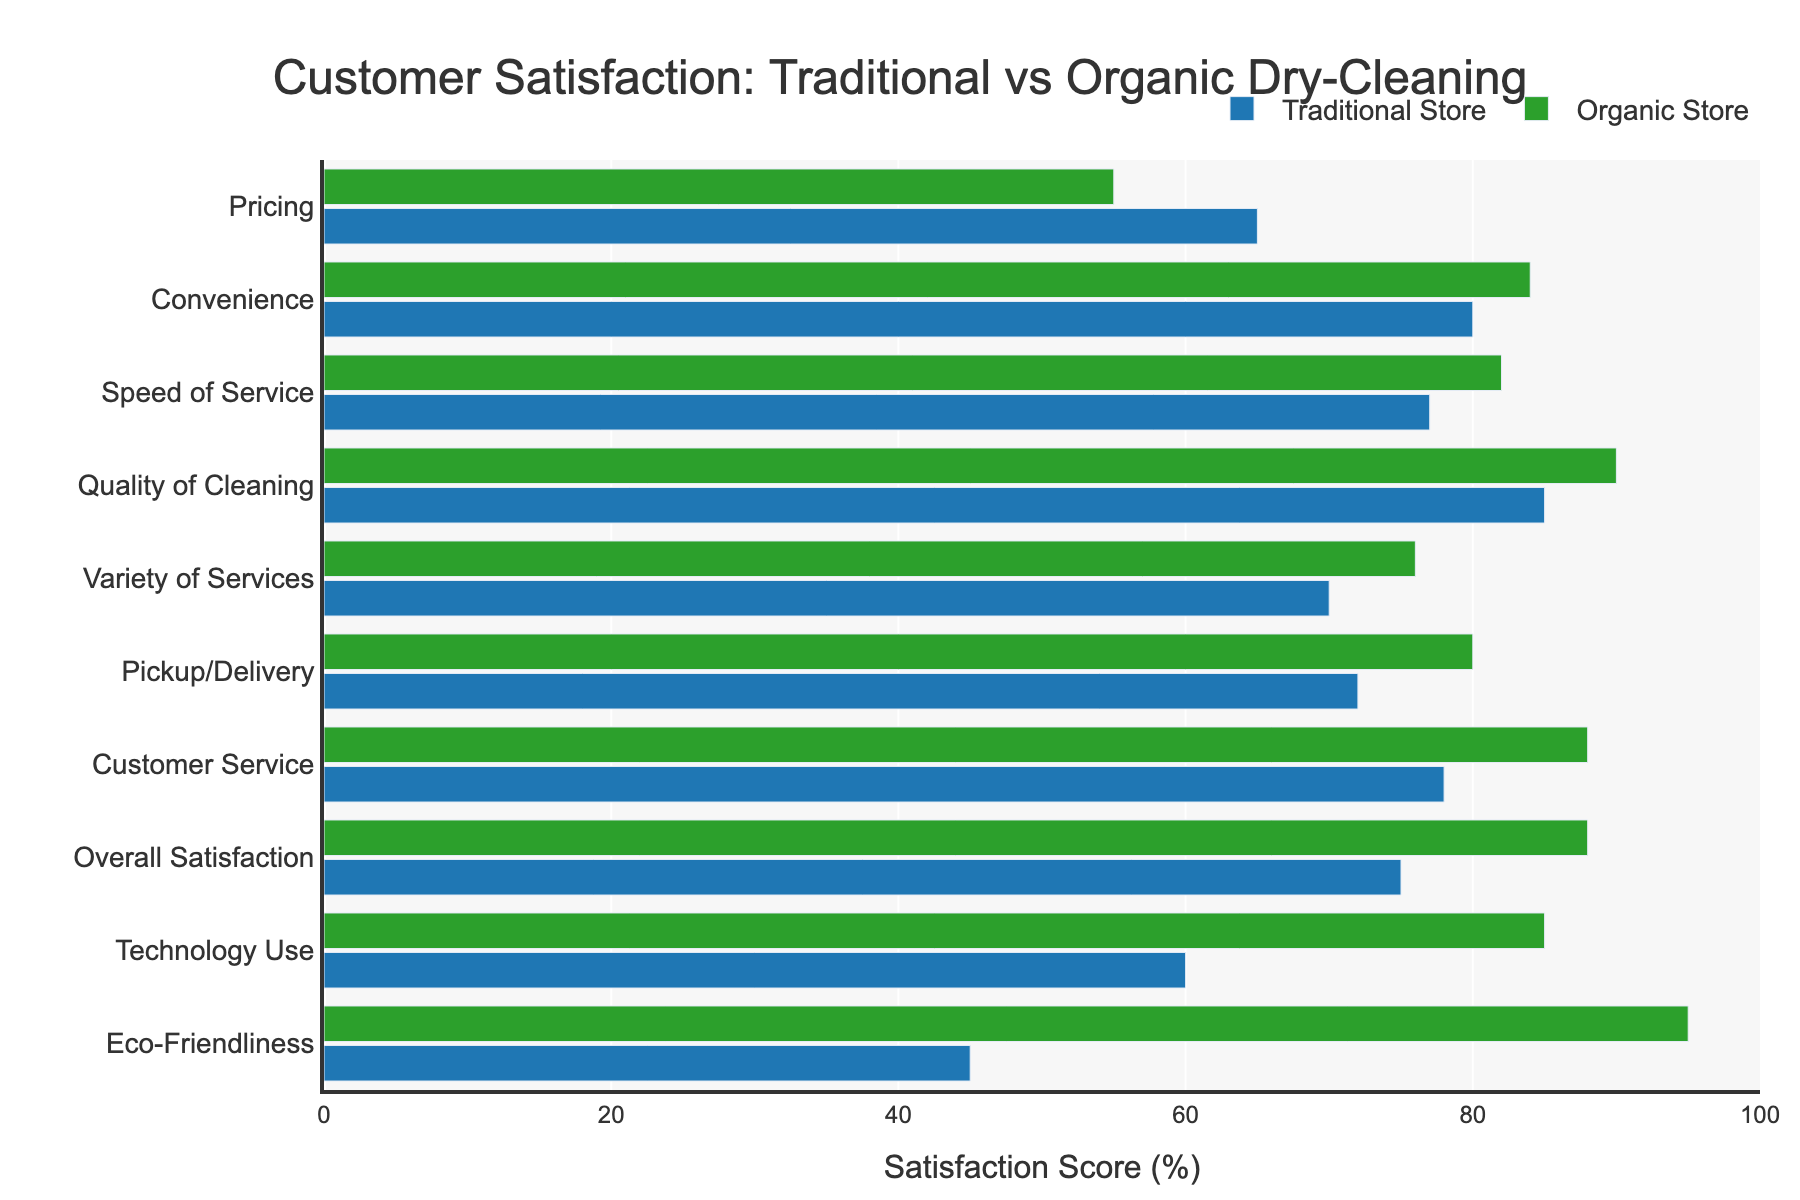Which satisfaction metric shows the largest difference in scores between traditional and organic stores? The largest difference can be found by looking for the metric with the longest bar gap between traditional and organic stores. 'Eco-Friendliness' has the largest difference with a score gap of 50% (traditional 45% vs organic 95%).
Answer: 'Eco-Friendliness' For which satisfaction metric do traditional stores score higher than organic stores? By checking the bars, traditional stores score higher than organic stores in:
- 'Pricing': 65% (traditional) vs 55% (organic)
Answer: 'Pricing' Which store type has a higher overall satisfaction score? By observing the bars for 'Overall Satisfaction', organic stores score 88% whereas traditional stores score 75%. Hence, organic stores have a higher overall satisfaction.
Answer: Organic stores What's the combined satisfaction score for organic stores in 'Customer Service' and 'Quality of Cleaning'? For organic stores, the 'Customer Service' score is 88% and 'Quality of Cleaning' score is 90%. The combined score is 88 + 90 = 178%.
Answer: 178% Which satisfaction metric shows the smallest difference in scores between traditional and organic stores? The smallest difference can be identified by looking for the metric with the closest bars. 'Convenience' shows the smallest difference where traditional stores score 80% and organic stores score 84%, translating to a 4% difference.
Answer: 'Convenience' Which metrics have a score of 80% or higher for traditional stores? The metrics with scores of 80% or higher for traditional stores are:
- 'Quality of Cleaning': 85%
- 'Convenience': 80%
Answer: 'Quality of Cleaning', 'Convenience' What is the average satisfaction score for traditional stores across all metrics? Adding up all the scores for traditional stores: 85 + 78 + 65 + 72 + 45 + 80 + 77 + 70 + 60 + 75 = 707%. Then, divide by the number of metrics, which is 10. So, the average score is 707/10 = 70.7%.
Answer: 70.7% How much higher is the 'Technology Use' score for organic stores compared to traditional stores? The 'Technology Use' score for organic stores is 85% and for traditional stores is 60%. The difference is 85 - 60 = 25%.
Answer: 25% Which metrics do organic stores score at least 10% higher than traditional stores? The metrics where organic stores score 10% or more than traditional stores:
- 'Eco-Friendliness': 95% (organic) - 45% (traditional) = 50%
- 'Technology Use': 85% (organic) - 60% (traditional) = 25%
- 'Customer Service': 88% (organic) - 78% (traditional) = 10%
- 'Pickup/Delivery': 80% (organic) - 72% (traditional) = 8%
- 'Quality of Cleaning': 90% (organic) - 85% (traditional) = 5%
Answer: 'Eco-Friendliness', 'Technology Use' What is the difference between the highest and lowest satisfaction scores for organic stores? The highest satisfaction score for organic stores is 'Eco-Friendliness' with 95% and the lowest is 'Pricing' with 55%. The difference is 95 - 55 = 40%.
Answer: 40% 